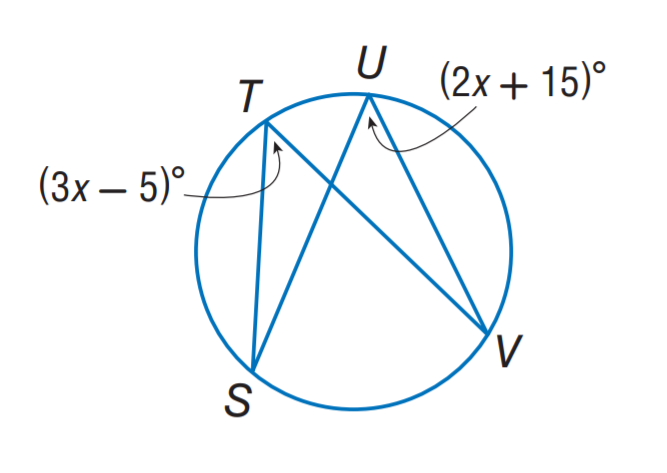Answer the mathemtical geometry problem and directly provide the correct option letter.
Question: If m \angle S = 3 x and m \angle V = x + 16, find m \angle S.
Choices: A: 16 B: 24 C: 32 D: 48 B 